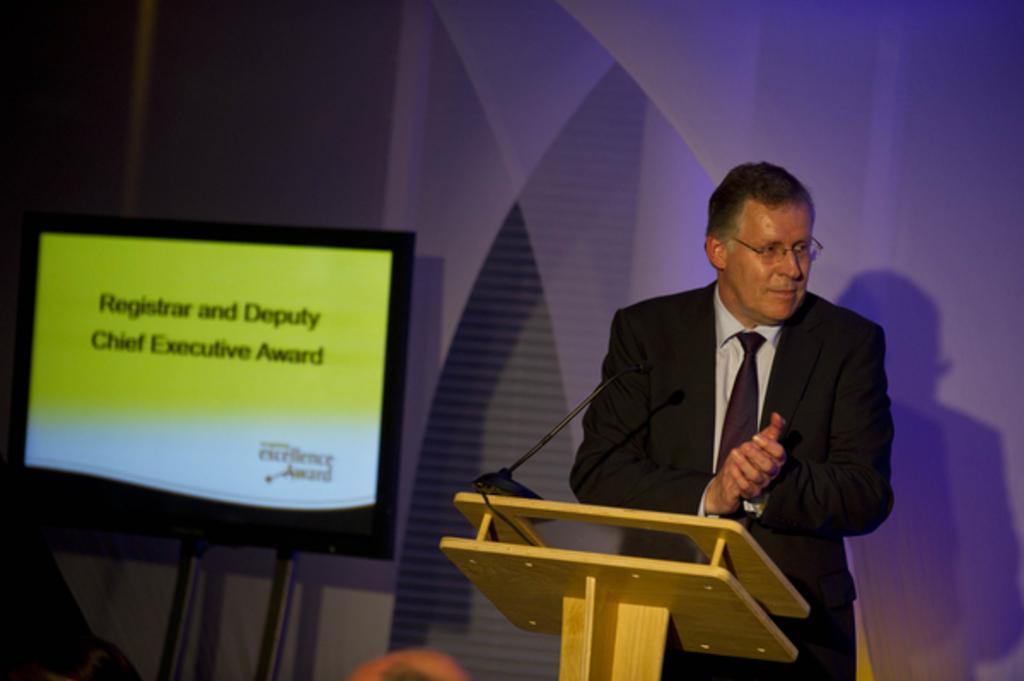Could you give a brief overview of what you see in this image? Here we can see that a person is standing and wearing a suit, and in front here is the microphone, and at side here is the television, and here is the wall. 